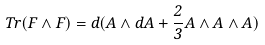<formula> <loc_0><loc_0><loc_500><loc_500>T r ( F \wedge F ) = d ( A \wedge d A + { \frac { 2 } { 3 } } A \wedge A \wedge A )</formula> 